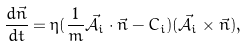Convert formula to latex. <formula><loc_0><loc_0><loc_500><loc_500>\frac { d \vec { n } } { d t } = \eta ( \frac { 1 } { m } \vec { \mathcal { A } } _ { i } \cdot \vec { n } - C _ { i } ) ( \vec { \mathcal { A } } _ { i } \times \vec { n } ) ,</formula> 